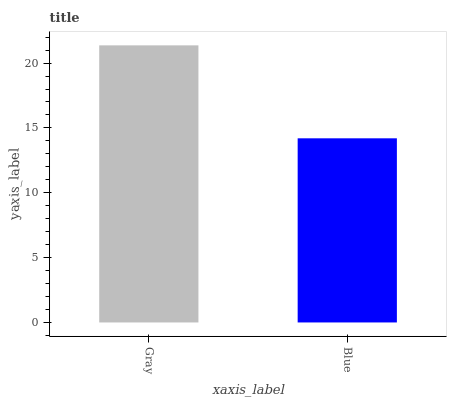Is Blue the minimum?
Answer yes or no. Yes. Is Gray the maximum?
Answer yes or no. Yes. Is Blue the maximum?
Answer yes or no. No. Is Gray greater than Blue?
Answer yes or no. Yes. Is Blue less than Gray?
Answer yes or no. Yes. Is Blue greater than Gray?
Answer yes or no. No. Is Gray less than Blue?
Answer yes or no. No. Is Gray the high median?
Answer yes or no. Yes. Is Blue the low median?
Answer yes or no. Yes. Is Blue the high median?
Answer yes or no. No. Is Gray the low median?
Answer yes or no. No. 